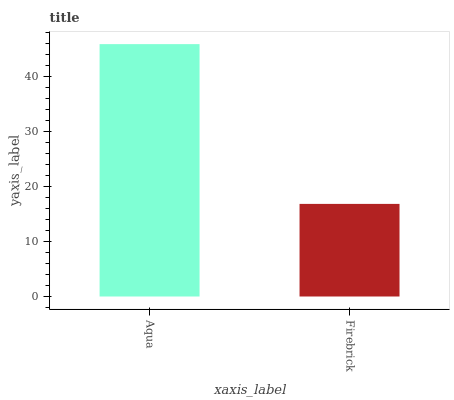Is Firebrick the minimum?
Answer yes or no. Yes. Is Aqua the maximum?
Answer yes or no. Yes. Is Firebrick the maximum?
Answer yes or no. No. Is Aqua greater than Firebrick?
Answer yes or no. Yes. Is Firebrick less than Aqua?
Answer yes or no. Yes. Is Firebrick greater than Aqua?
Answer yes or no. No. Is Aqua less than Firebrick?
Answer yes or no. No. Is Aqua the high median?
Answer yes or no. Yes. Is Firebrick the low median?
Answer yes or no. Yes. Is Firebrick the high median?
Answer yes or no. No. Is Aqua the low median?
Answer yes or no. No. 